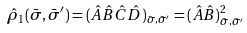Convert formula to latex. <formula><loc_0><loc_0><loc_500><loc_500>\hat { \rho } _ { 1 } ( \bar { \sigma } , \bar { \sigma } ^ { \prime } ) = ( \hat { A } \hat { B } \hat { C } \hat { D } ) _ { \bar { \sigma } , \bar { \sigma } ^ { \prime } } = ( \hat { A } \hat { B } ) _ { \bar { \sigma } , \bar { \sigma } ^ { \prime } } ^ { 2 }</formula> 